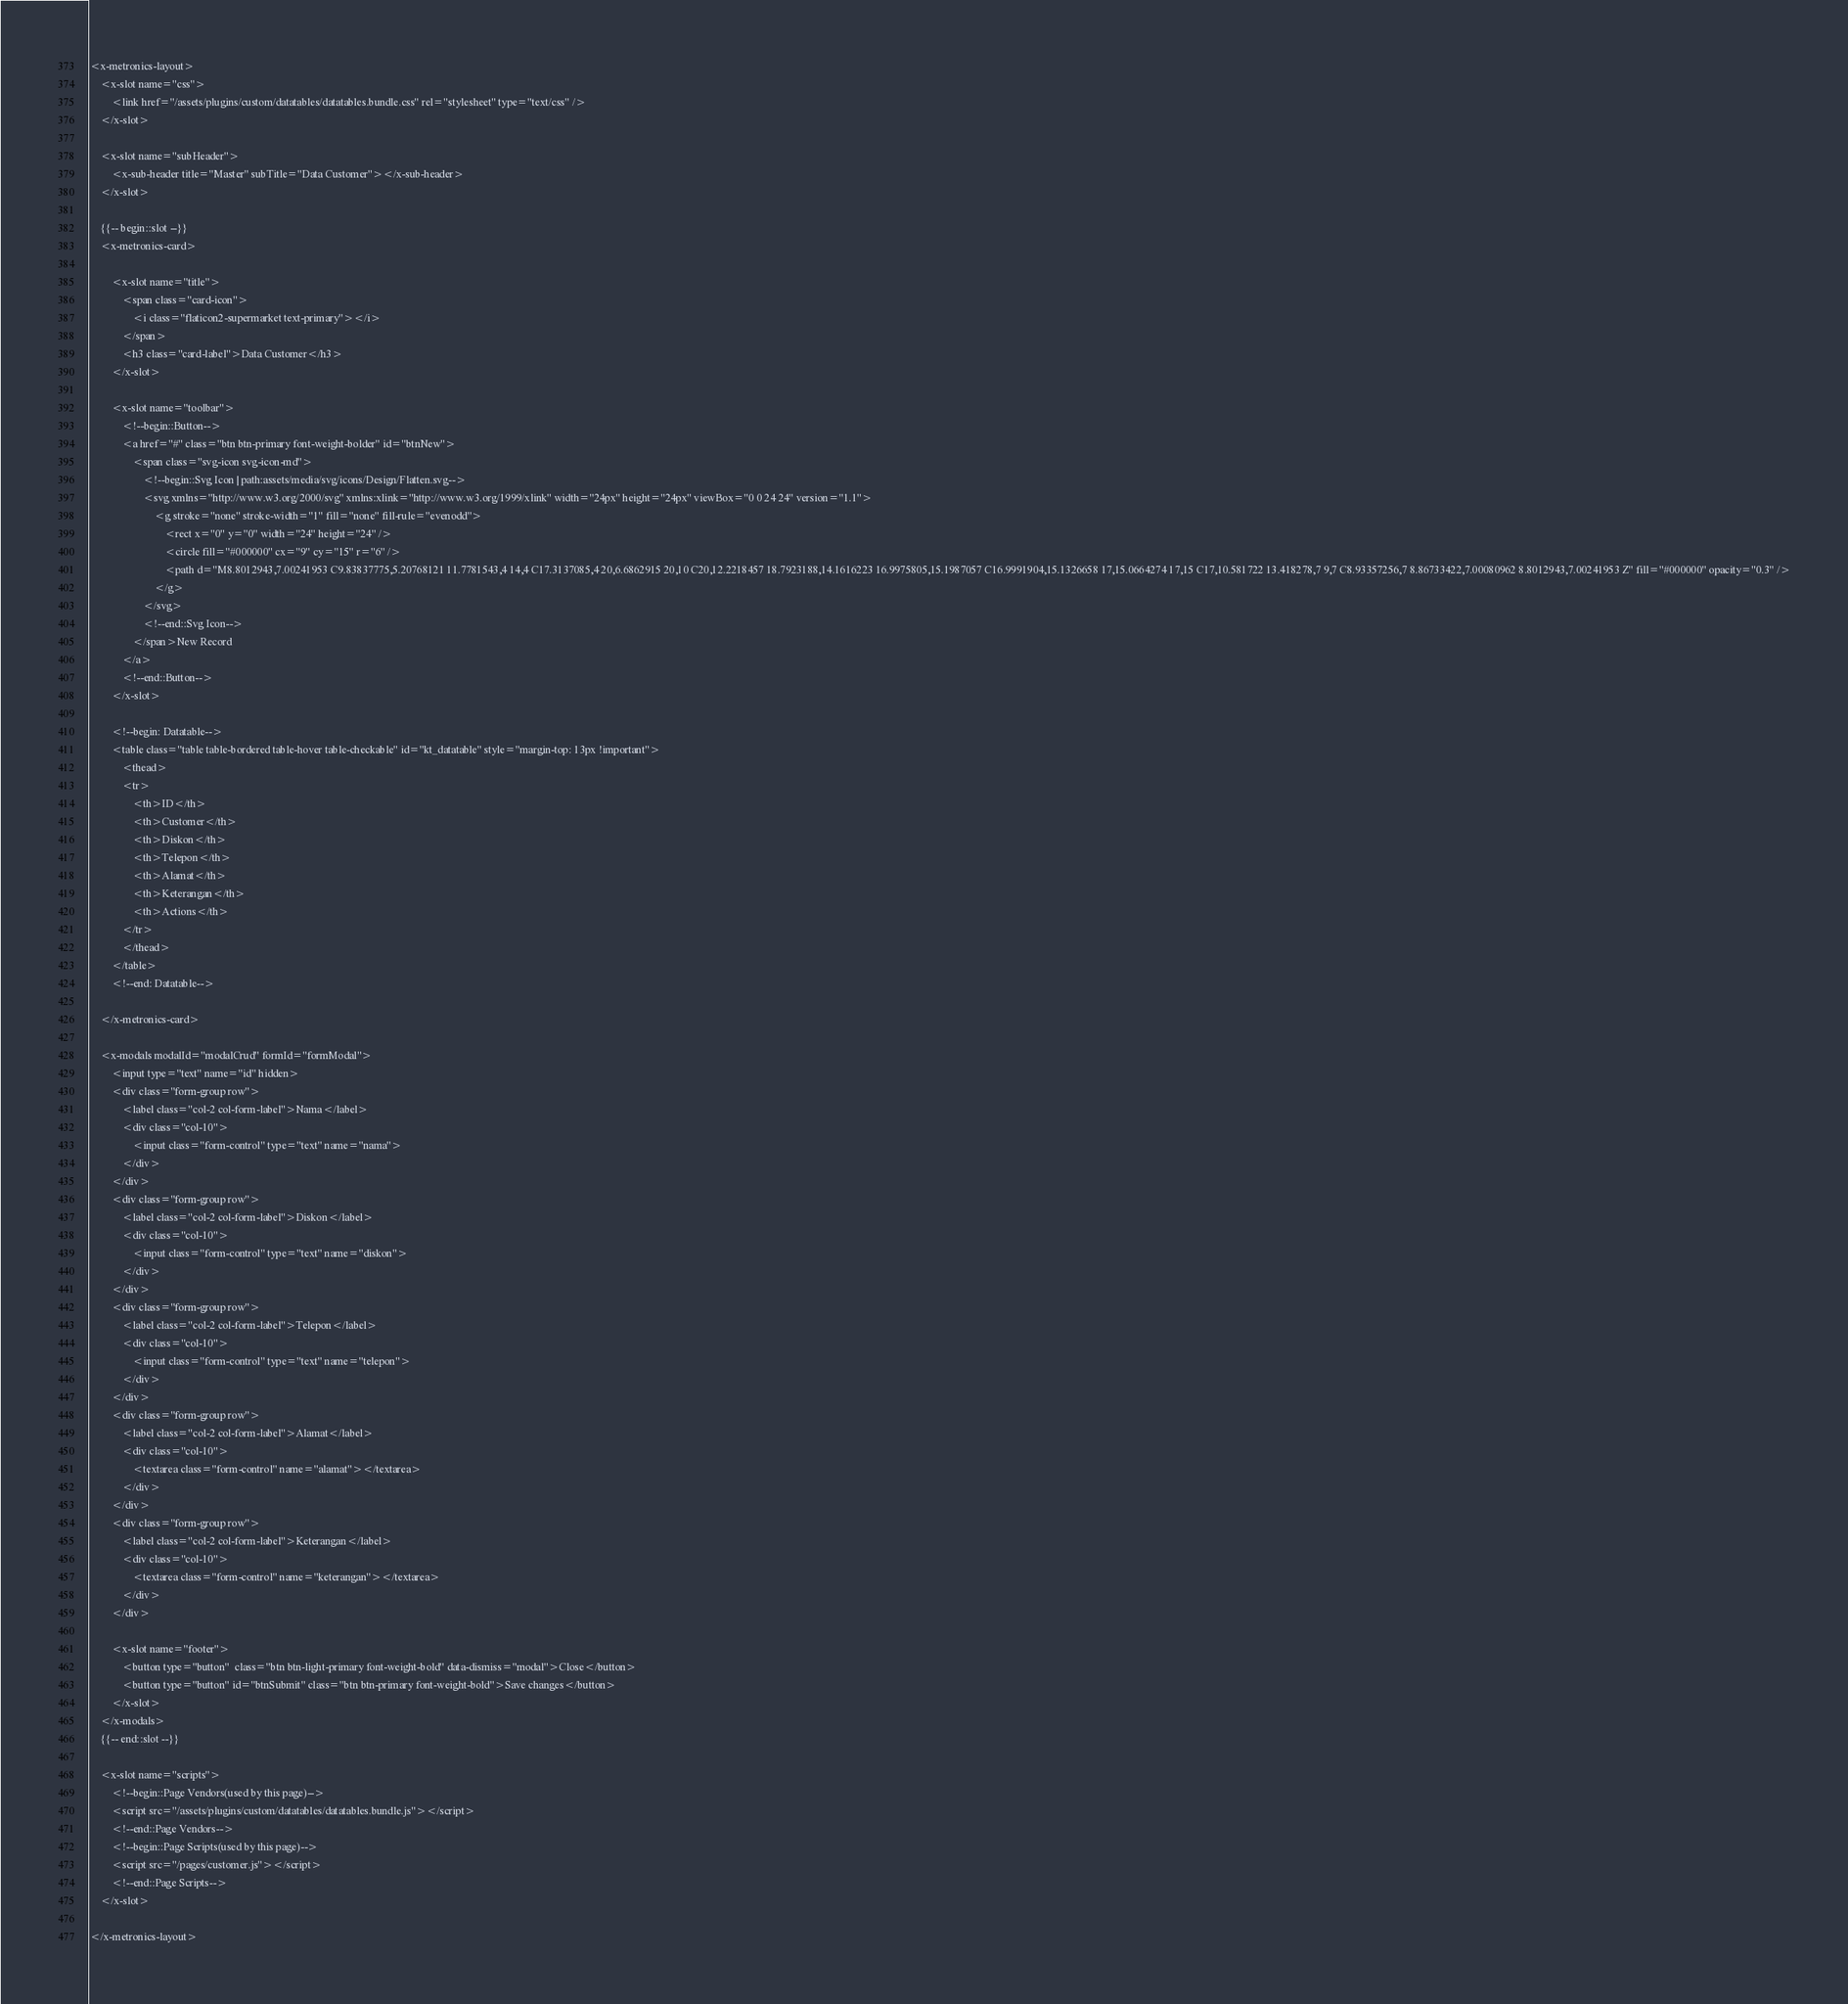<code> <loc_0><loc_0><loc_500><loc_500><_PHP_><x-metronics-layout>
    <x-slot name="css">
        <link href="/assets/plugins/custom/datatables/datatables.bundle.css" rel="stylesheet" type="text/css" />
    </x-slot>

    <x-slot name="subHeader">
        <x-sub-header title="Master" subTitle="Data Customer"></x-sub-header>
    </x-slot>

    {{-- begin::slot --}}
    <x-metronics-card>

        <x-slot name="title">
            <span class="card-icon">
                <i class="flaticon2-supermarket text-primary"></i>
            </span>
            <h3 class="card-label">Data Customer</h3>
        </x-slot>

        <x-slot name="toolbar">
            <!--begin::Button-->
            <a href="#" class="btn btn-primary font-weight-bolder" id="btnNew">
                <span class="svg-icon svg-icon-md">
                    <!--begin::Svg Icon | path:assets/media/svg/icons/Design/Flatten.svg-->
                    <svg xmlns="http://www.w3.org/2000/svg" xmlns:xlink="http://www.w3.org/1999/xlink" width="24px" height="24px" viewBox="0 0 24 24" version="1.1">
                        <g stroke="none" stroke-width="1" fill="none" fill-rule="evenodd">
                            <rect x="0" y="0" width="24" height="24" />
                            <circle fill="#000000" cx="9" cy="15" r="6" />
                            <path d="M8.8012943,7.00241953 C9.83837775,5.20768121 11.7781543,4 14,4 C17.3137085,4 20,6.6862915 20,10 C20,12.2218457 18.7923188,14.1616223 16.9975805,15.1987057 C16.9991904,15.1326658 17,15.0664274 17,15 C17,10.581722 13.418278,7 9,7 C8.93357256,7 8.86733422,7.00080962 8.8012943,7.00241953 Z" fill="#000000" opacity="0.3" />
                        </g>
                    </svg>
                    <!--end::Svg Icon-->
                </span>New Record
            </a>
            <!--end::Button-->
        </x-slot>

        <!--begin: Datatable-->
        <table class="table table-bordered table-hover table-checkable" id="kt_datatable" style="margin-top: 13px !important">
            <thead>
            <tr>
                <th>ID</th>
                <th>Customer</th>
                <th>Diskon</th>
                <th>Telepon</th>
                <th>Alamat</th>
                <th>Keterangan</th>
                <th>Actions</th>
            </tr>
            </thead>
        </table>
        <!--end: Datatable-->

    </x-metronics-card>

    <x-modals modalId="modalCrud" formId="formModal">
        <input type="text" name="id" hidden>
        <div class="form-group row">
            <label class="col-2 col-form-label">Nama</label>
            <div class="col-10">
                <input class="form-control" type="text" name="nama">
            </div>
        </div>
        <div class="form-group row">
            <label class="col-2 col-form-label">Diskon</label>
            <div class="col-10">
                <input class="form-control" type="text" name="diskon">
            </div>
        </div>
        <div class="form-group row">
            <label class="col-2 col-form-label">Telepon</label>
            <div class="col-10">
                <input class="form-control" type="text" name="telepon">
            </div>
        </div>
        <div class="form-group row">
            <label class="col-2 col-form-label">Alamat</label>
            <div class="col-10">
                <textarea class="form-control" name="alamat"></textarea>
            </div>
        </div>
        <div class="form-group row">
            <label class="col-2 col-form-label">Keterangan</label>
            <div class="col-10">
                <textarea class="form-control" name="keterangan"></textarea>
            </div>
        </div>

        <x-slot name="footer">
            <button type="button"  class="btn btn-light-primary font-weight-bold" data-dismiss="modal">Close</button>
            <button type="button" id="btnSubmit" class="btn btn-primary font-weight-bold">Save changes</button>
        </x-slot>
    </x-modals>
    {{-- end::slot --}}

    <x-slot name="scripts">
        <!--begin::Page Vendors(used by this page)-->
        <script src="/assets/plugins/custom/datatables/datatables.bundle.js"></script>
        <!--end::Page Vendors-->
        <!--begin::Page Scripts(used by this page)-->
        <script src="/pages/customer.js"></script>
        <!--end::Page Scripts-->
    </x-slot>

</x-metronics-layout>
</code> 